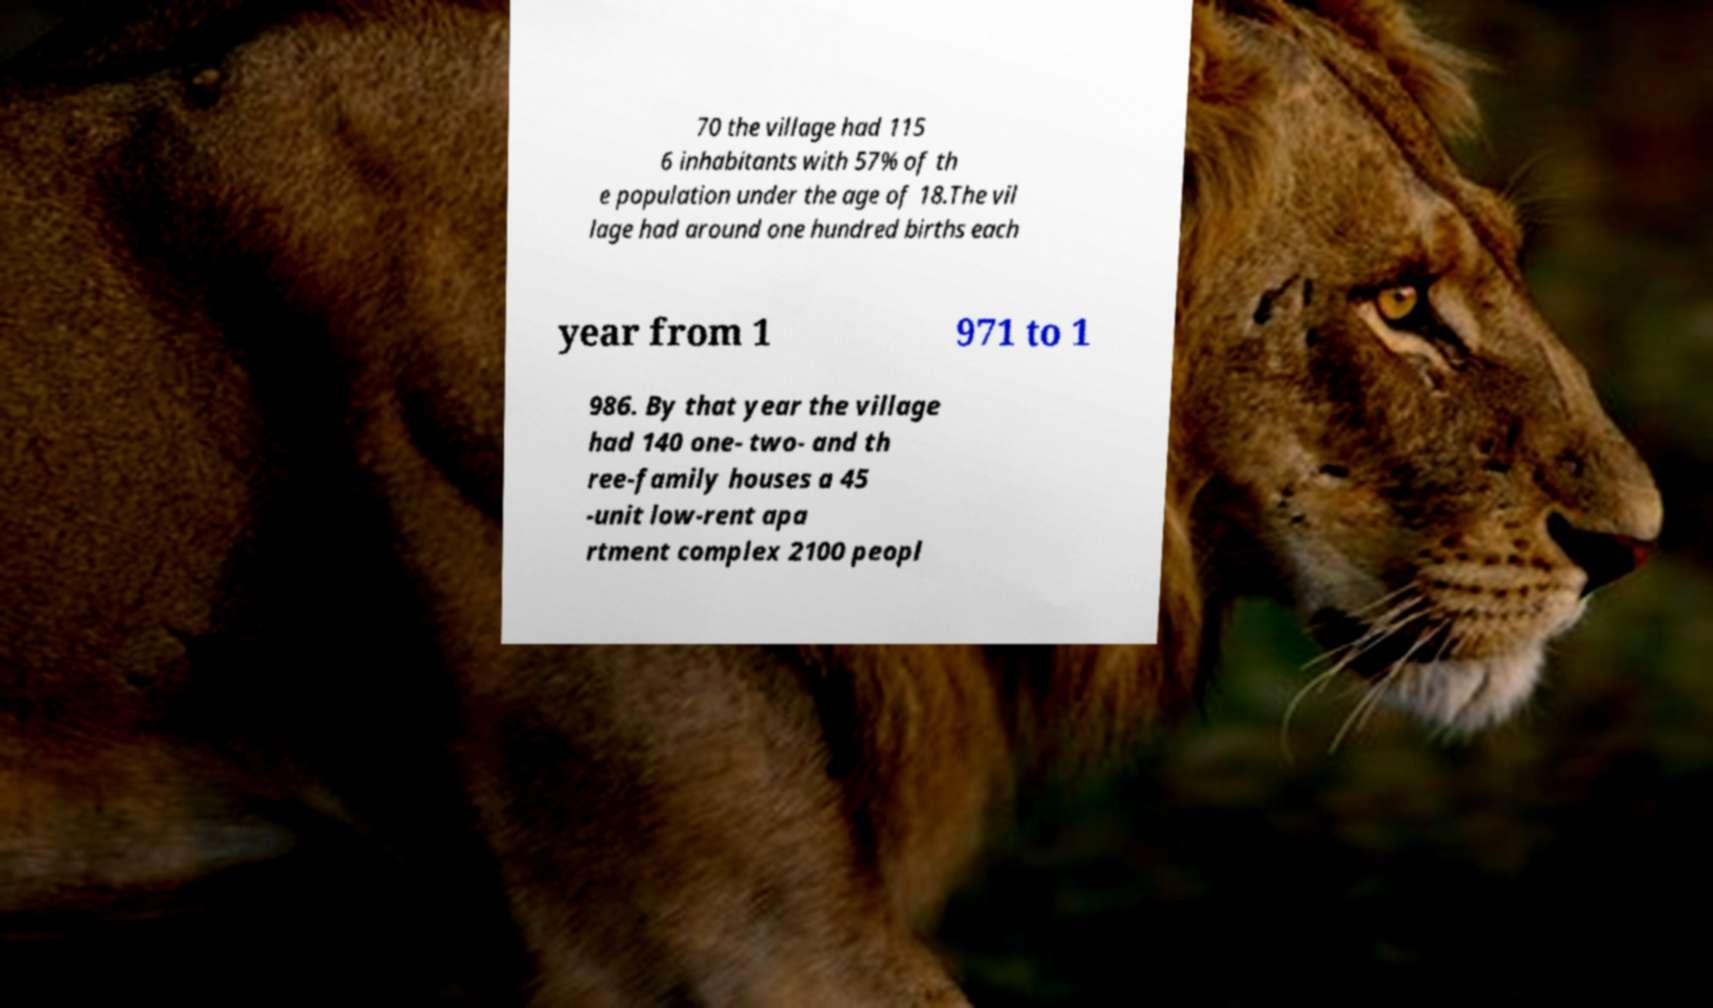Could you assist in decoding the text presented in this image and type it out clearly? 70 the village had 115 6 inhabitants with 57% of th e population under the age of 18.The vil lage had around one hundred births each year from 1 971 to 1 986. By that year the village had 140 one- two- and th ree-family houses a 45 -unit low-rent apa rtment complex 2100 peopl 